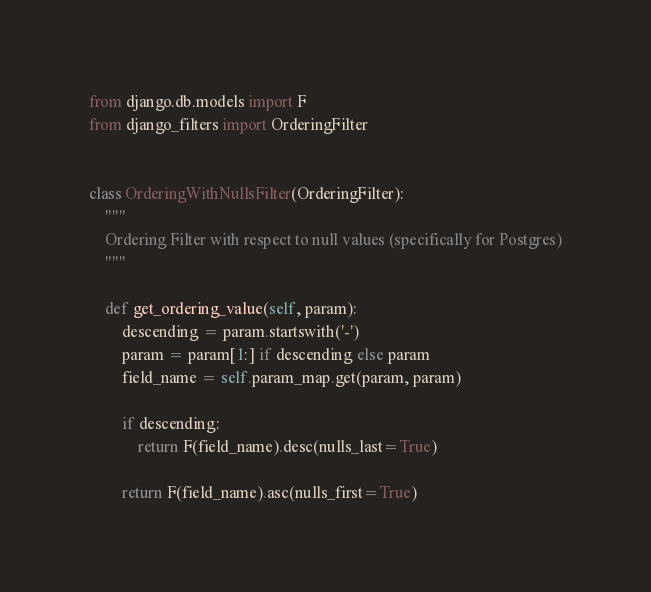Convert code to text. <code><loc_0><loc_0><loc_500><loc_500><_Python_>from django.db.models import F
from django_filters import OrderingFilter


class OrderingWithNullsFilter(OrderingFilter):
    """
    Ordering Filter with respect to null values (specifically for Postgres)
    """

    def get_ordering_value(self, param):
        descending = param.startswith('-')
        param = param[1:] if descending else param
        field_name = self.param_map.get(param, param)

        if descending:
            return F(field_name).desc(nulls_last=True)

        return F(field_name).asc(nulls_first=True)
</code> 